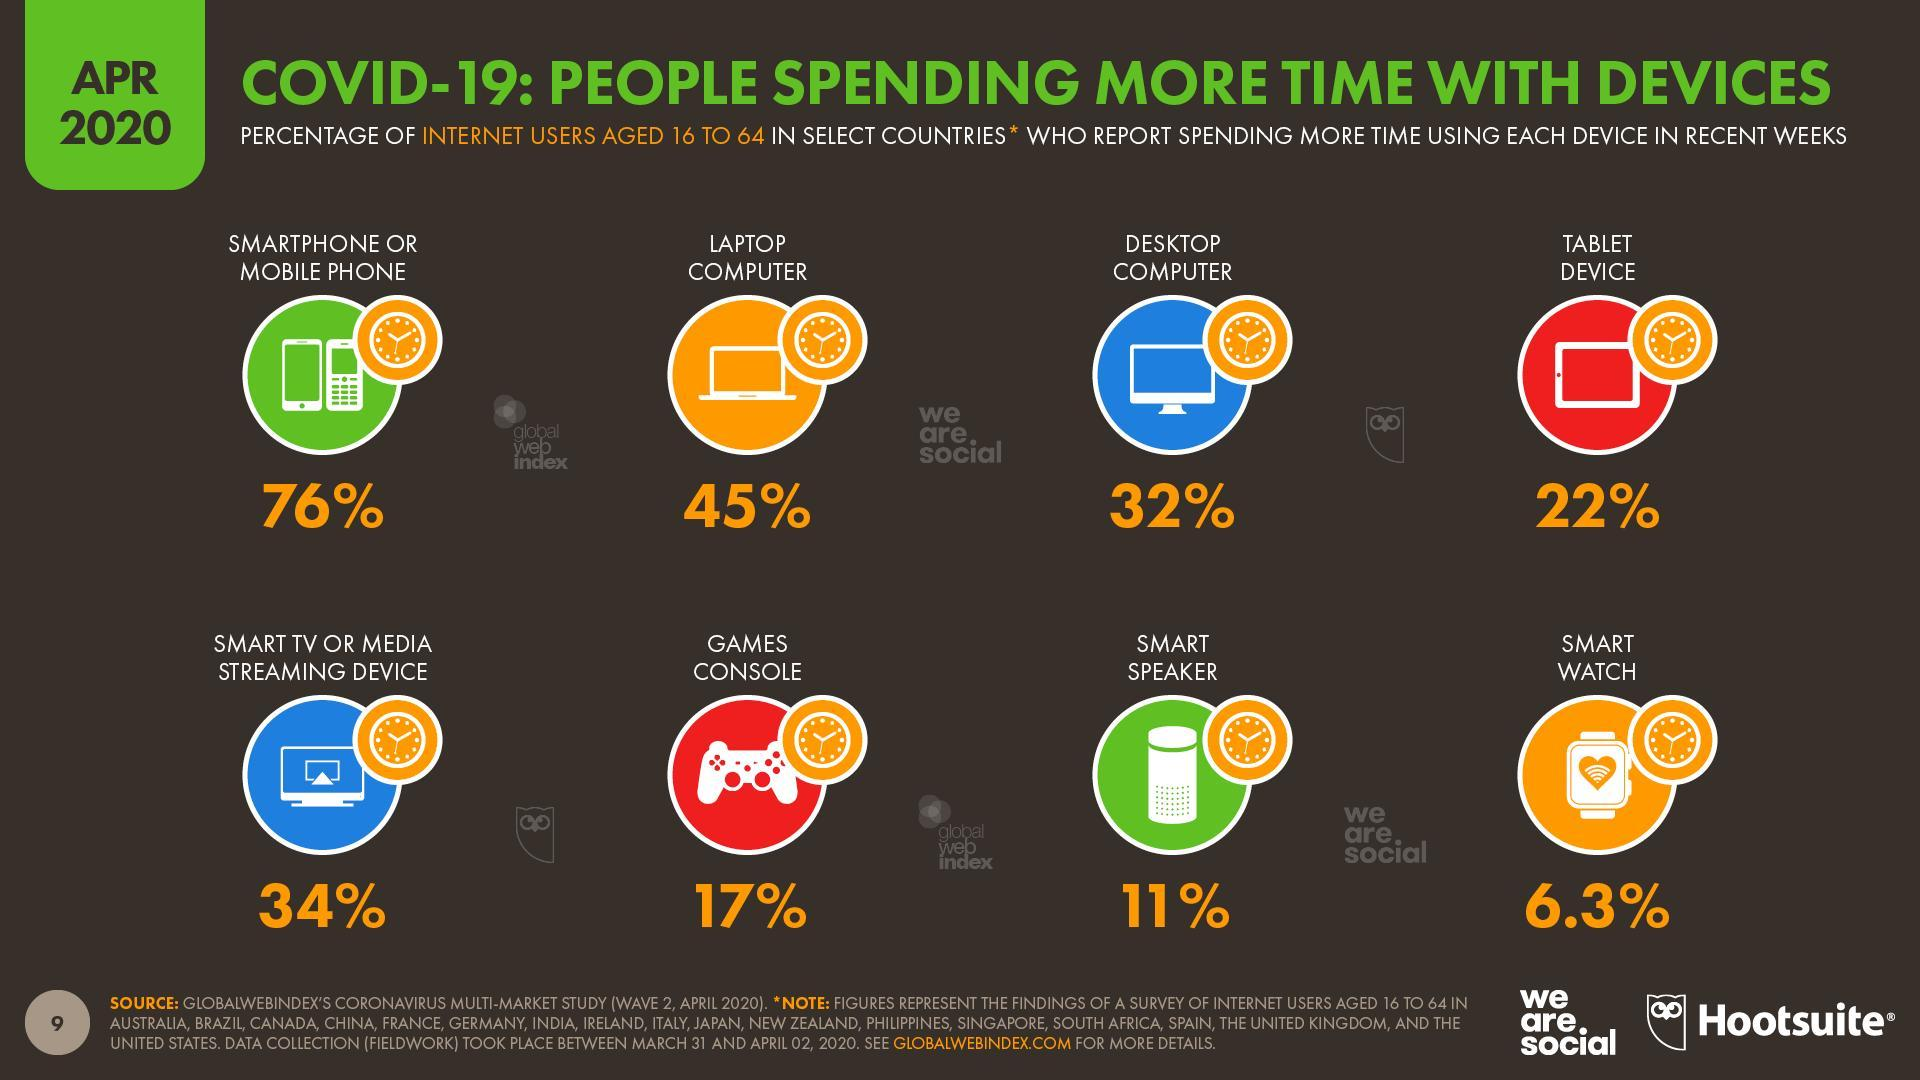How many people reported spending more time on laptop computer?
Answer the question with a short phrase. 45% Which device is used by the second lowest percent of users? smart speaker How many of the internet users spent more time on tablet devices? 22% 6.3% of internet users spent more time using which device? smart watch Which devices are used by less than 10% of the internet users? smart watch Which device is used by the second highest percent of users? Laptop computer What percent of people spent more time on smart TV or media streaming device? 34% The highest number of people spent more time on which device? smartphone or mobile phone How many of the users used gaming consoles? 17% Which device is used by 32% of the internet users? desktop computer 